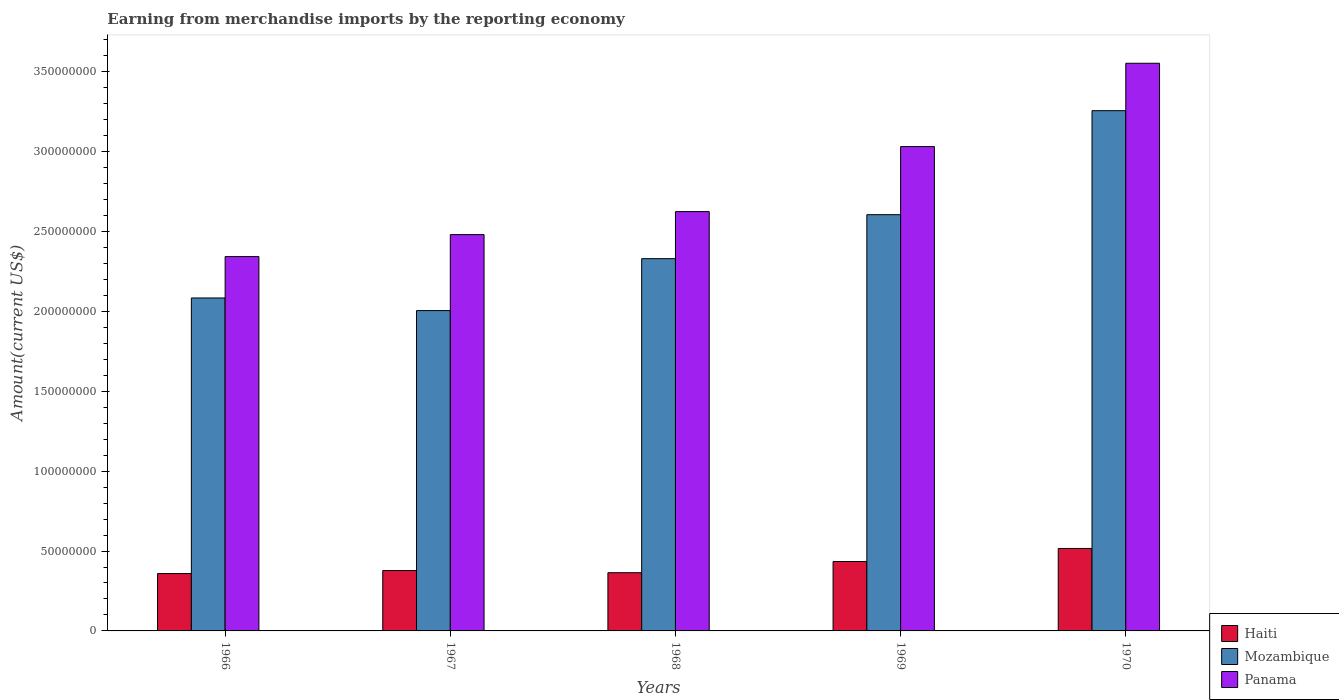How many groups of bars are there?
Provide a short and direct response. 5. Are the number of bars per tick equal to the number of legend labels?
Provide a succinct answer. Yes. Are the number of bars on each tick of the X-axis equal?
Your answer should be very brief. Yes. How many bars are there on the 4th tick from the left?
Make the answer very short. 3. How many bars are there on the 2nd tick from the right?
Your answer should be compact. 3. What is the amount earned from merchandise imports in Haiti in 1970?
Your answer should be compact. 5.16e+07. Across all years, what is the maximum amount earned from merchandise imports in Panama?
Ensure brevity in your answer.  3.55e+08. Across all years, what is the minimum amount earned from merchandise imports in Haiti?
Offer a very short reply. 3.59e+07. In which year was the amount earned from merchandise imports in Panama minimum?
Offer a very short reply. 1966. What is the total amount earned from merchandise imports in Haiti in the graph?
Your answer should be very brief. 2.05e+08. What is the difference between the amount earned from merchandise imports in Panama in 1966 and that in 1970?
Provide a succinct answer. -1.21e+08. What is the difference between the amount earned from merchandise imports in Haiti in 1970 and the amount earned from merchandise imports in Panama in 1967?
Provide a succinct answer. -1.96e+08. What is the average amount earned from merchandise imports in Haiti per year?
Keep it short and to the point. 4.10e+07. In the year 1967, what is the difference between the amount earned from merchandise imports in Mozambique and amount earned from merchandise imports in Panama?
Ensure brevity in your answer.  -4.76e+07. In how many years, is the amount earned from merchandise imports in Panama greater than 30000000 US$?
Offer a very short reply. 5. What is the ratio of the amount earned from merchandise imports in Panama in 1967 to that in 1968?
Offer a terse response. 0.95. What is the difference between the highest and the second highest amount earned from merchandise imports in Panama?
Your response must be concise. 5.22e+07. What is the difference between the highest and the lowest amount earned from merchandise imports in Panama?
Offer a very short reply. 1.21e+08. Is the sum of the amount earned from merchandise imports in Haiti in 1966 and 1967 greater than the maximum amount earned from merchandise imports in Mozambique across all years?
Offer a terse response. No. What does the 2nd bar from the left in 1969 represents?
Your response must be concise. Mozambique. What does the 3rd bar from the right in 1966 represents?
Your answer should be compact. Haiti. What is the difference between two consecutive major ticks on the Y-axis?
Make the answer very short. 5.00e+07. Does the graph contain grids?
Keep it short and to the point. No. Where does the legend appear in the graph?
Your answer should be very brief. Bottom right. What is the title of the graph?
Make the answer very short. Earning from merchandise imports by the reporting economy. What is the label or title of the X-axis?
Offer a very short reply. Years. What is the label or title of the Y-axis?
Make the answer very short. Amount(current US$). What is the Amount(current US$) of Haiti in 1966?
Offer a very short reply. 3.59e+07. What is the Amount(current US$) in Mozambique in 1966?
Provide a succinct answer. 2.08e+08. What is the Amount(current US$) of Panama in 1966?
Provide a succinct answer. 2.34e+08. What is the Amount(current US$) of Haiti in 1967?
Your response must be concise. 3.78e+07. What is the Amount(current US$) in Mozambique in 1967?
Your answer should be compact. 2.00e+08. What is the Amount(current US$) in Panama in 1967?
Provide a succinct answer. 2.48e+08. What is the Amount(current US$) in Haiti in 1968?
Offer a terse response. 3.64e+07. What is the Amount(current US$) of Mozambique in 1968?
Offer a terse response. 2.33e+08. What is the Amount(current US$) in Panama in 1968?
Provide a succinct answer. 2.62e+08. What is the Amount(current US$) of Haiti in 1969?
Give a very brief answer. 4.34e+07. What is the Amount(current US$) of Mozambique in 1969?
Provide a succinct answer. 2.61e+08. What is the Amount(current US$) in Panama in 1969?
Your answer should be very brief. 3.03e+08. What is the Amount(current US$) in Haiti in 1970?
Your answer should be very brief. 5.16e+07. What is the Amount(current US$) of Mozambique in 1970?
Provide a succinct answer. 3.26e+08. What is the Amount(current US$) of Panama in 1970?
Make the answer very short. 3.55e+08. Across all years, what is the maximum Amount(current US$) of Haiti?
Your answer should be very brief. 5.16e+07. Across all years, what is the maximum Amount(current US$) of Mozambique?
Provide a succinct answer. 3.26e+08. Across all years, what is the maximum Amount(current US$) in Panama?
Your answer should be very brief. 3.55e+08. Across all years, what is the minimum Amount(current US$) in Haiti?
Give a very brief answer. 3.59e+07. Across all years, what is the minimum Amount(current US$) of Mozambique?
Provide a succinct answer. 2.00e+08. Across all years, what is the minimum Amount(current US$) of Panama?
Provide a short and direct response. 2.34e+08. What is the total Amount(current US$) of Haiti in the graph?
Offer a very short reply. 2.05e+08. What is the total Amount(current US$) of Mozambique in the graph?
Offer a very short reply. 1.23e+09. What is the total Amount(current US$) in Panama in the graph?
Ensure brevity in your answer.  1.40e+09. What is the difference between the Amount(current US$) in Haiti in 1966 and that in 1967?
Your response must be concise. -1.88e+06. What is the difference between the Amount(current US$) in Mozambique in 1966 and that in 1967?
Your answer should be compact. 7.90e+06. What is the difference between the Amount(current US$) of Panama in 1966 and that in 1967?
Offer a very short reply. -1.38e+07. What is the difference between the Amount(current US$) of Haiti in 1966 and that in 1968?
Provide a short and direct response. -5.35e+05. What is the difference between the Amount(current US$) in Mozambique in 1966 and that in 1968?
Ensure brevity in your answer.  -2.46e+07. What is the difference between the Amount(current US$) in Panama in 1966 and that in 1968?
Provide a short and direct response. -2.82e+07. What is the difference between the Amount(current US$) in Haiti in 1966 and that in 1969?
Ensure brevity in your answer.  -7.53e+06. What is the difference between the Amount(current US$) of Mozambique in 1966 and that in 1969?
Offer a very short reply. -5.21e+07. What is the difference between the Amount(current US$) in Panama in 1966 and that in 1969?
Your response must be concise. -6.88e+07. What is the difference between the Amount(current US$) in Haiti in 1966 and that in 1970?
Make the answer very short. -1.57e+07. What is the difference between the Amount(current US$) in Mozambique in 1966 and that in 1970?
Provide a succinct answer. -1.17e+08. What is the difference between the Amount(current US$) of Panama in 1966 and that in 1970?
Offer a terse response. -1.21e+08. What is the difference between the Amount(current US$) of Haiti in 1967 and that in 1968?
Offer a terse response. 1.34e+06. What is the difference between the Amount(current US$) in Mozambique in 1967 and that in 1968?
Provide a succinct answer. -3.25e+07. What is the difference between the Amount(current US$) of Panama in 1967 and that in 1968?
Your answer should be very brief. -1.44e+07. What is the difference between the Amount(current US$) in Haiti in 1967 and that in 1969?
Your response must be concise. -5.66e+06. What is the difference between the Amount(current US$) in Mozambique in 1967 and that in 1969?
Ensure brevity in your answer.  -6.00e+07. What is the difference between the Amount(current US$) of Panama in 1967 and that in 1969?
Your answer should be compact. -5.51e+07. What is the difference between the Amount(current US$) of Haiti in 1967 and that in 1970?
Offer a very short reply. -1.38e+07. What is the difference between the Amount(current US$) in Mozambique in 1967 and that in 1970?
Provide a short and direct response. -1.25e+08. What is the difference between the Amount(current US$) in Panama in 1967 and that in 1970?
Ensure brevity in your answer.  -1.07e+08. What is the difference between the Amount(current US$) of Haiti in 1968 and that in 1969?
Ensure brevity in your answer.  -7.00e+06. What is the difference between the Amount(current US$) of Mozambique in 1968 and that in 1969?
Offer a very short reply. -2.75e+07. What is the difference between the Amount(current US$) of Panama in 1968 and that in 1969?
Offer a terse response. -4.07e+07. What is the difference between the Amount(current US$) in Haiti in 1968 and that in 1970?
Ensure brevity in your answer.  -1.52e+07. What is the difference between the Amount(current US$) in Mozambique in 1968 and that in 1970?
Your response must be concise. -9.26e+07. What is the difference between the Amount(current US$) in Panama in 1968 and that in 1970?
Give a very brief answer. -9.28e+07. What is the difference between the Amount(current US$) in Haiti in 1969 and that in 1970?
Make the answer very short. -8.17e+06. What is the difference between the Amount(current US$) in Mozambique in 1969 and that in 1970?
Provide a short and direct response. -6.51e+07. What is the difference between the Amount(current US$) of Panama in 1969 and that in 1970?
Your answer should be very brief. -5.22e+07. What is the difference between the Amount(current US$) of Haiti in 1966 and the Amount(current US$) of Mozambique in 1967?
Offer a very short reply. -1.65e+08. What is the difference between the Amount(current US$) of Haiti in 1966 and the Amount(current US$) of Panama in 1967?
Offer a terse response. -2.12e+08. What is the difference between the Amount(current US$) of Mozambique in 1966 and the Amount(current US$) of Panama in 1967?
Your answer should be very brief. -3.96e+07. What is the difference between the Amount(current US$) in Haiti in 1966 and the Amount(current US$) in Mozambique in 1968?
Offer a very short reply. -1.97e+08. What is the difference between the Amount(current US$) in Haiti in 1966 and the Amount(current US$) in Panama in 1968?
Offer a terse response. -2.27e+08. What is the difference between the Amount(current US$) of Mozambique in 1966 and the Amount(current US$) of Panama in 1968?
Keep it short and to the point. -5.41e+07. What is the difference between the Amount(current US$) of Haiti in 1966 and the Amount(current US$) of Mozambique in 1969?
Make the answer very short. -2.25e+08. What is the difference between the Amount(current US$) in Haiti in 1966 and the Amount(current US$) in Panama in 1969?
Keep it short and to the point. -2.67e+08. What is the difference between the Amount(current US$) in Mozambique in 1966 and the Amount(current US$) in Panama in 1969?
Provide a succinct answer. -9.48e+07. What is the difference between the Amount(current US$) of Haiti in 1966 and the Amount(current US$) of Mozambique in 1970?
Provide a short and direct response. -2.90e+08. What is the difference between the Amount(current US$) in Haiti in 1966 and the Amount(current US$) in Panama in 1970?
Keep it short and to the point. -3.19e+08. What is the difference between the Amount(current US$) of Mozambique in 1966 and the Amount(current US$) of Panama in 1970?
Keep it short and to the point. -1.47e+08. What is the difference between the Amount(current US$) of Haiti in 1967 and the Amount(current US$) of Mozambique in 1968?
Keep it short and to the point. -1.95e+08. What is the difference between the Amount(current US$) in Haiti in 1967 and the Amount(current US$) in Panama in 1968?
Provide a succinct answer. -2.25e+08. What is the difference between the Amount(current US$) in Mozambique in 1967 and the Amount(current US$) in Panama in 1968?
Your answer should be compact. -6.20e+07. What is the difference between the Amount(current US$) in Haiti in 1967 and the Amount(current US$) in Mozambique in 1969?
Your answer should be compact. -2.23e+08. What is the difference between the Amount(current US$) of Haiti in 1967 and the Amount(current US$) of Panama in 1969?
Offer a terse response. -2.65e+08. What is the difference between the Amount(current US$) in Mozambique in 1967 and the Amount(current US$) in Panama in 1969?
Make the answer very short. -1.03e+08. What is the difference between the Amount(current US$) in Haiti in 1967 and the Amount(current US$) in Mozambique in 1970?
Offer a terse response. -2.88e+08. What is the difference between the Amount(current US$) of Haiti in 1967 and the Amount(current US$) of Panama in 1970?
Give a very brief answer. -3.18e+08. What is the difference between the Amount(current US$) in Mozambique in 1967 and the Amount(current US$) in Panama in 1970?
Your answer should be very brief. -1.55e+08. What is the difference between the Amount(current US$) in Haiti in 1968 and the Amount(current US$) in Mozambique in 1969?
Your response must be concise. -2.24e+08. What is the difference between the Amount(current US$) of Haiti in 1968 and the Amount(current US$) of Panama in 1969?
Your response must be concise. -2.67e+08. What is the difference between the Amount(current US$) in Mozambique in 1968 and the Amount(current US$) in Panama in 1969?
Your answer should be very brief. -7.02e+07. What is the difference between the Amount(current US$) of Haiti in 1968 and the Amount(current US$) of Mozambique in 1970?
Provide a short and direct response. -2.89e+08. What is the difference between the Amount(current US$) in Haiti in 1968 and the Amount(current US$) in Panama in 1970?
Offer a very short reply. -3.19e+08. What is the difference between the Amount(current US$) of Mozambique in 1968 and the Amount(current US$) of Panama in 1970?
Your answer should be very brief. -1.22e+08. What is the difference between the Amount(current US$) of Haiti in 1969 and the Amount(current US$) of Mozambique in 1970?
Offer a terse response. -2.82e+08. What is the difference between the Amount(current US$) of Haiti in 1969 and the Amount(current US$) of Panama in 1970?
Your answer should be compact. -3.12e+08. What is the difference between the Amount(current US$) of Mozambique in 1969 and the Amount(current US$) of Panama in 1970?
Offer a terse response. -9.48e+07. What is the average Amount(current US$) in Haiti per year?
Your answer should be compact. 4.10e+07. What is the average Amount(current US$) in Mozambique per year?
Make the answer very short. 2.46e+08. What is the average Amount(current US$) in Panama per year?
Provide a succinct answer. 2.81e+08. In the year 1966, what is the difference between the Amount(current US$) in Haiti and Amount(current US$) in Mozambique?
Ensure brevity in your answer.  -1.72e+08. In the year 1966, what is the difference between the Amount(current US$) of Haiti and Amount(current US$) of Panama?
Offer a terse response. -1.98e+08. In the year 1966, what is the difference between the Amount(current US$) in Mozambique and Amount(current US$) in Panama?
Your answer should be compact. -2.59e+07. In the year 1967, what is the difference between the Amount(current US$) in Haiti and Amount(current US$) in Mozambique?
Offer a terse response. -1.63e+08. In the year 1967, what is the difference between the Amount(current US$) in Haiti and Amount(current US$) in Panama?
Provide a short and direct response. -2.10e+08. In the year 1967, what is the difference between the Amount(current US$) in Mozambique and Amount(current US$) in Panama?
Offer a very short reply. -4.76e+07. In the year 1968, what is the difference between the Amount(current US$) of Haiti and Amount(current US$) of Mozambique?
Offer a terse response. -1.97e+08. In the year 1968, what is the difference between the Amount(current US$) in Haiti and Amount(current US$) in Panama?
Ensure brevity in your answer.  -2.26e+08. In the year 1968, what is the difference between the Amount(current US$) of Mozambique and Amount(current US$) of Panama?
Ensure brevity in your answer.  -2.95e+07. In the year 1969, what is the difference between the Amount(current US$) of Haiti and Amount(current US$) of Mozambique?
Ensure brevity in your answer.  -2.17e+08. In the year 1969, what is the difference between the Amount(current US$) of Haiti and Amount(current US$) of Panama?
Provide a short and direct response. -2.60e+08. In the year 1969, what is the difference between the Amount(current US$) of Mozambique and Amount(current US$) of Panama?
Offer a terse response. -4.26e+07. In the year 1970, what is the difference between the Amount(current US$) of Haiti and Amount(current US$) of Mozambique?
Make the answer very short. -2.74e+08. In the year 1970, what is the difference between the Amount(current US$) of Haiti and Amount(current US$) of Panama?
Offer a very short reply. -3.04e+08. In the year 1970, what is the difference between the Amount(current US$) in Mozambique and Amount(current US$) in Panama?
Offer a very short reply. -2.97e+07. What is the ratio of the Amount(current US$) of Haiti in 1966 to that in 1967?
Your response must be concise. 0.95. What is the ratio of the Amount(current US$) in Mozambique in 1966 to that in 1967?
Offer a very short reply. 1.04. What is the ratio of the Amount(current US$) in Panama in 1966 to that in 1967?
Your answer should be compact. 0.94. What is the ratio of the Amount(current US$) of Mozambique in 1966 to that in 1968?
Your answer should be very brief. 0.89. What is the ratio of the Amount(current US$) in Panama in 1966 to that in 1968?
Your response must be concise. 0.89. What is the ratio of the Amount(current US$) of Haiti in 1966 to that in 1969?
Your answer should be very brief. 0.83. What is the ratio of the Amount(current US$) of Mozambique in 1966 to that in 1969?
Your answer should be very brief. 0.8. What is the ratio of the Amount(current US$) of Panama in 1966 to that in 1969?
Offer a very short reply. 0.77. What is the ratio of the Amount(current US$) in Haiti in 1966 to that in 1970?
Keep it short and to the point. 0.7. What is the ratio of the Amount(current US$) of Mozambique in 1966 to that in 1970?
Provide a short and direct response. 0.64. What is the ratio of the Amount(current US$) in Panama in 1966 to that in 1970?
Provide a succinct answer. 0.66. What is the ratio of the Amount(current US$) of Haiti in 1967 to that in 1968?
Your answer should be very brief. 1.04. What is the ratio of the Amount(current US$) of Mozambique in 1967 to that in 1968?
Keep it short and to the point. 0.86. What is the ratio of the Amount(current US$) in Panama in 1967 to that in 1968?
Ensure brevity in your answer.  0.95. What is the ratio of the Amount(current US$) in Haiti in 1967 to that in 1969?
Keep it short and to the point. 0.87. What is the ratio of the Amount(current US$) in Mozambique in 1967 to that in 1969?
Provide a succinct answer. 0.77. What is the ratio of the Amount(current US$) of Panama in 1967 to that in 1969?
Your answer should be compact. 0.82. What is the ratio of the Amount(current US$) of Haiti in 1967 to that in 1970?
Keep it short and to the point. 0.73. What is the ratio of the Amount(current US$) of Mozambique in 1967 to that in 1970?
Provide a succinct answer. 0.62. What is the ratio of the Amount(current US$) in Panama in 1967 to that in 1970?
Your response must be concise. 0.7. What is the ratio of the Amount(current US$) of Haiti in 1968 to that in 1969?
Your answer should be very brief. 0.84. What is the ratio of the Amount(current US$) of Mozambique in 1968 to that in 1969?
Your response must be concise. 0.89. What is the ratio of the Amount(current US$) of Panama in 1968 to that in 1969?
Provide a succinct answer. 0.87. What is the ratio of the Amount(current US$) in Haiti in 1968 to that in 1970?
Make the answer very short. 0.71. What is the ratio of the Amount(current US$) of Mozambique in 1968 to that in 1970?
Ensure brevity in your answer.  0.72. What is the ratio of the Amount(current US$) in Panama in 1968 to that in 1970?
Your answer should be compact. 0.74. What is the ratio of the Amount(current US$) in Haiti in 1969 to that in 1970?
Offer a very short reply. 0.84. What is the ratio of the Amount(current US$) of Mozambique in 1969 to that in 1970?
Provide a short and direct response. 0.8. What is the ratio of the Amount(current US$) of Panama in 1969 to that in 1970?
Provide a succinct answer. 0.85. What is the difference between the highest and the second highest Amount(current US$) in Haiti?
Keep it short and to the point. 8.17e+06. What is the difference between the highest and the second highest Amount(current US$) of Mozambique?
Offer a very short reply. 6.51e+07. What is the difference between the highest and the second highest Amount(current US$) in Panama?
Your response must be concise. 5.22e+07. What is the difference between the highest and the lowest Amount(current US$) in Haiti?
Give a very brief answer. 1.57e+07. What is the difference between the highest and the lowest Amount(current US$) of Mozambique?
Your answer should be very brief. 1.25e+08. What is the difference between the highest and the lowest Amount(current US$) of Panama?
Give a very brief answer. 1.21e+08. 